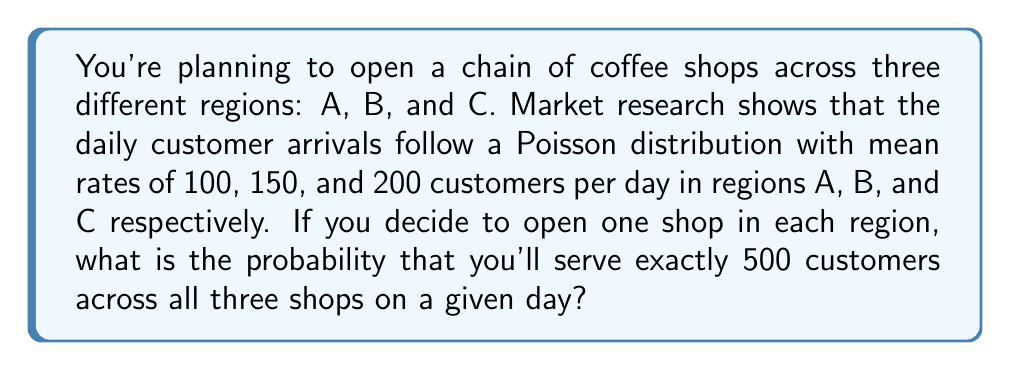Help me with this question. Let's approach this step-by-step:

1) First, we need to understand that the sum of independent Poisson distributions is also a Poisson distribution. The mean of the sum is the sum of the individual means.

2) In this case, the total mean across all three regions is:
   $\lambda_{total} = 100 + 150 + 200 = 450$ customers per day

3) We want to find the probability of exactly 500 customers across all shops. This can be calculated using the Poisson probability mass function:

   $$P(X = k) = \frac{e^{-\lambda}\lambda^k}{k!}$$

   Where $\lambda$ is the mean and $k$ is the number of occurrences.

4) Plugging in our values:
   $$P(X = 500) = \frac{e^{-450}450^{500}}{500!}$$

5) This can be calculated using a scientific calculator or a computer:

   $$P(X = 500) \approx 0.0188$$

6) Therefore, the probability of serving exactly 500 customers across all three shops on a given day is approximately 0.0188 or 1.88%.
Answer: 0.0188 